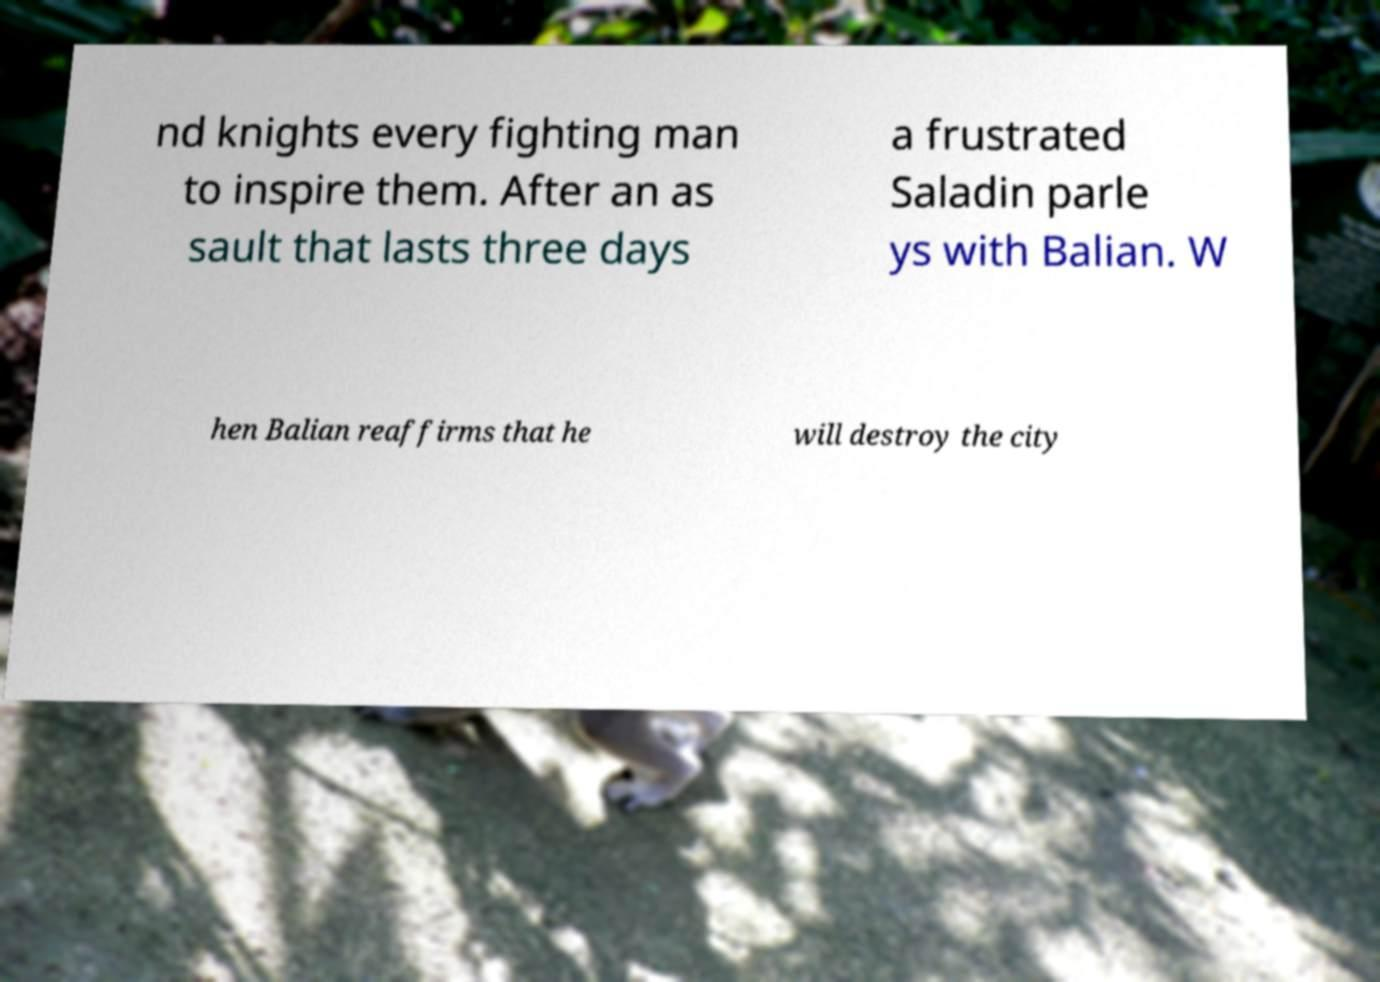Could you assist in decoding the text presented in this image and type it out clearly? nd knights every fighting man to inspire them. After an as sault that lasts three days a frustrated Saladin parle ys with Balian. W hen Balian reaffirms that he will destroy the city 